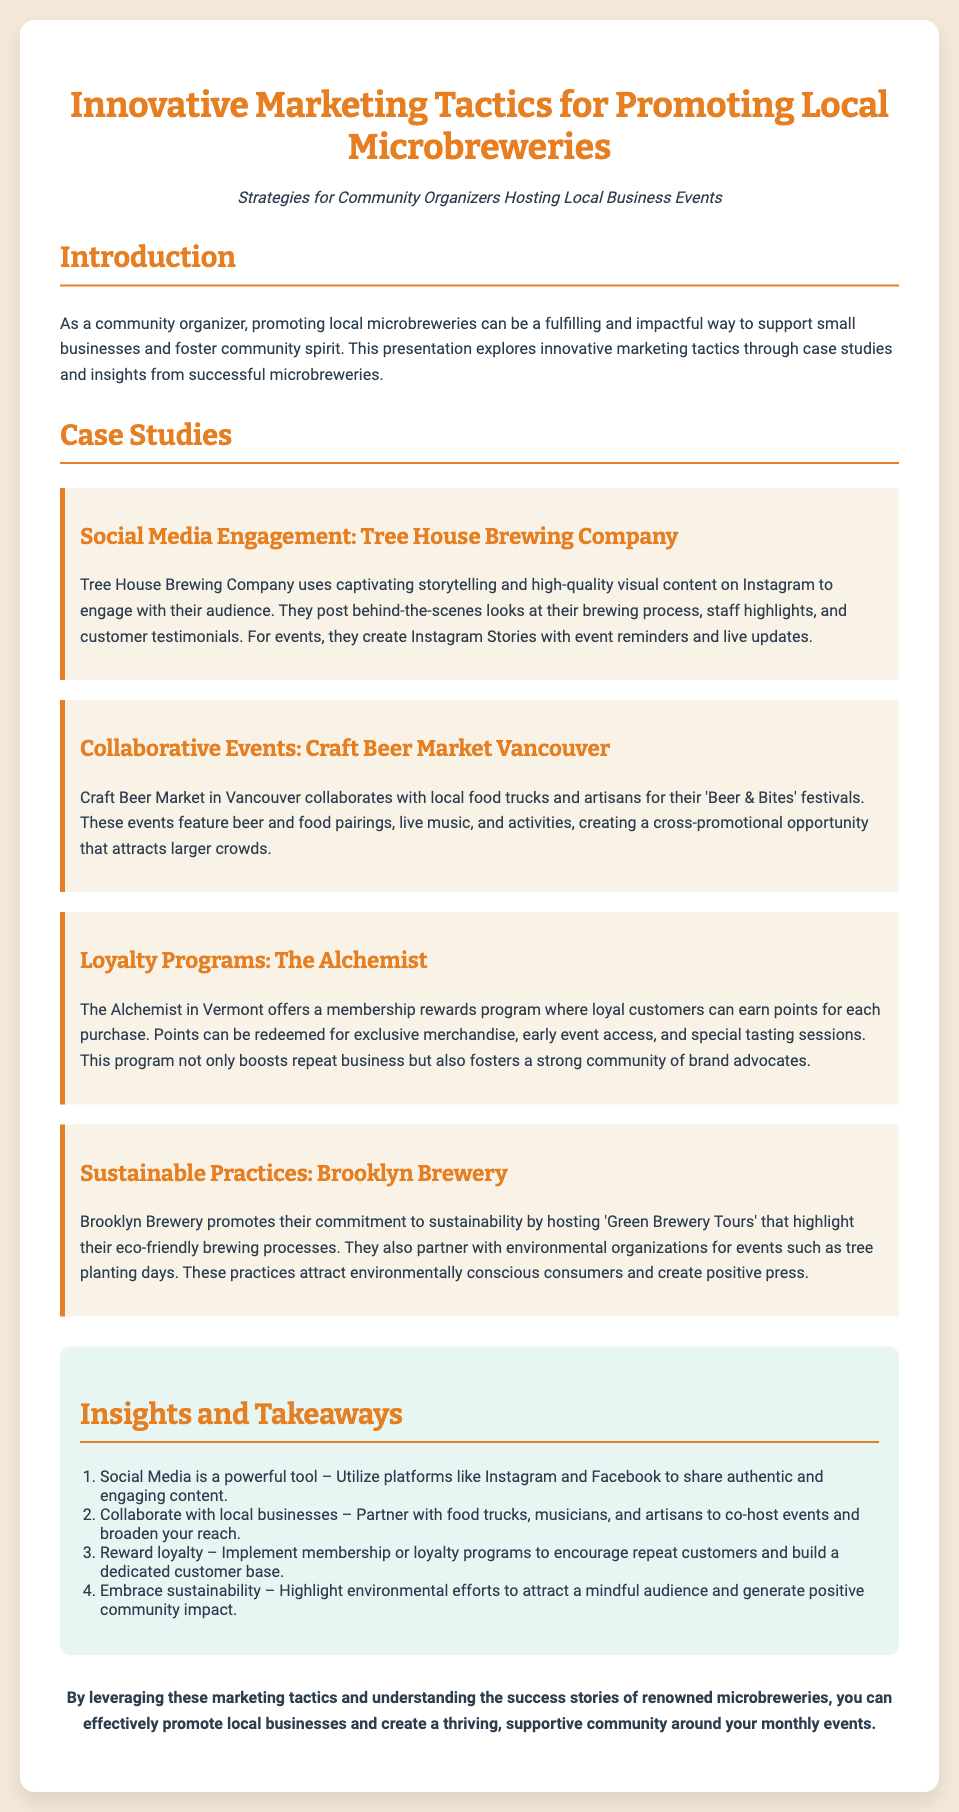what is the title of the presentation? The title of the presentation is provided at the top of the slide, introducing the main topic of discussion.
Answer: Innovative Marketing Tactics for Promoting Local Microbreweries who is the case study about social media engagement? The case study focused on social media engagement specifically highlights a successful microbrewery's strategies.
Answer: Tree House Brewing Company what type of events does Craft Beer Market Vancouver collaborate on? The document specifies the type of collaborative events that take place as highlighted in the case study.
Answer: 'Beer & Bites' festivals what loyalty program does The Alchemist offer? The loyalty program mentioned involves how customers can earn points and what they can redeem them for.
Answer: Membership rewards program how does Brooklyn Brewery promote sustainability? This question relates to the specific initiatives Brooklyn Brewery uses to highlight their sustainable practices.
Answer: 'Green Brewery Tours' how many insights are listed in the document? The total number of insights provided in the insights section indicates how concise the overall takeaways are.
Answer: Four what is the overall goal of the marketing tactics presented? The conclusion of the document emphasizes the intended purpose behind the marketing strategies discussed.
Answer: Effectively promote local businesses which social media platform is specifically mentioned for engagement? The document mentions specific platforms that are important for engaging with the audience in its marketing tactics.
Answer: Instagram 